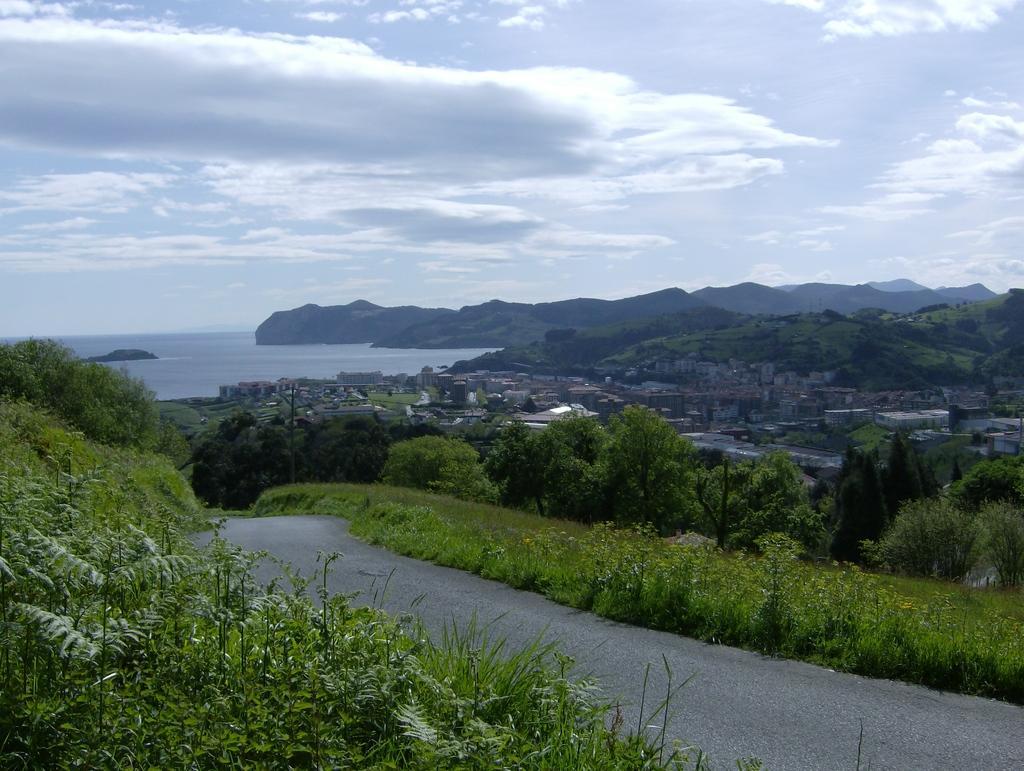Can you describe this image briefly? In this image we can see a sea. There are many hills in the image There are many trees and plants in the image. There is a road in the image. There are many houses and buildings in the image. 